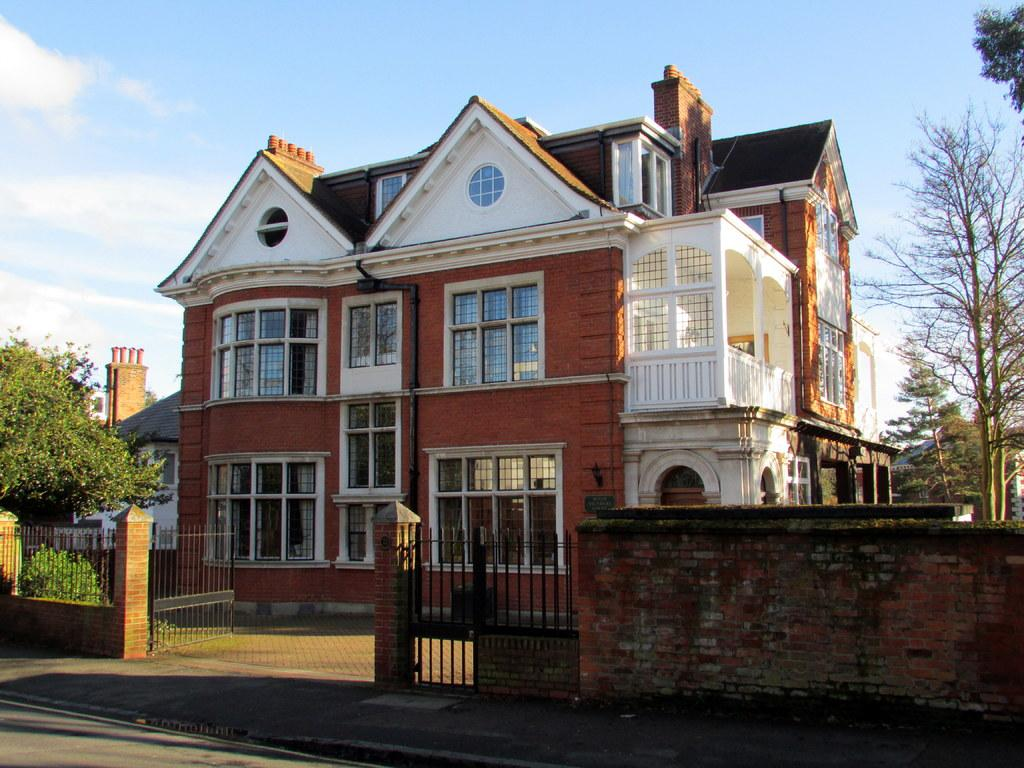What type of structure is visible in the image? There is a building in the image. What can be seen around the building? There are trees around the building. What is in front of the building? There is a wall in front of the building. Is there any entrance or exit visible in the image? Yes, there is a gate beside the wall. What flavor of coat is the building wearing in the image? Buildings do not wear coats, and therefore there is no coat or flavor to consider in the image. 